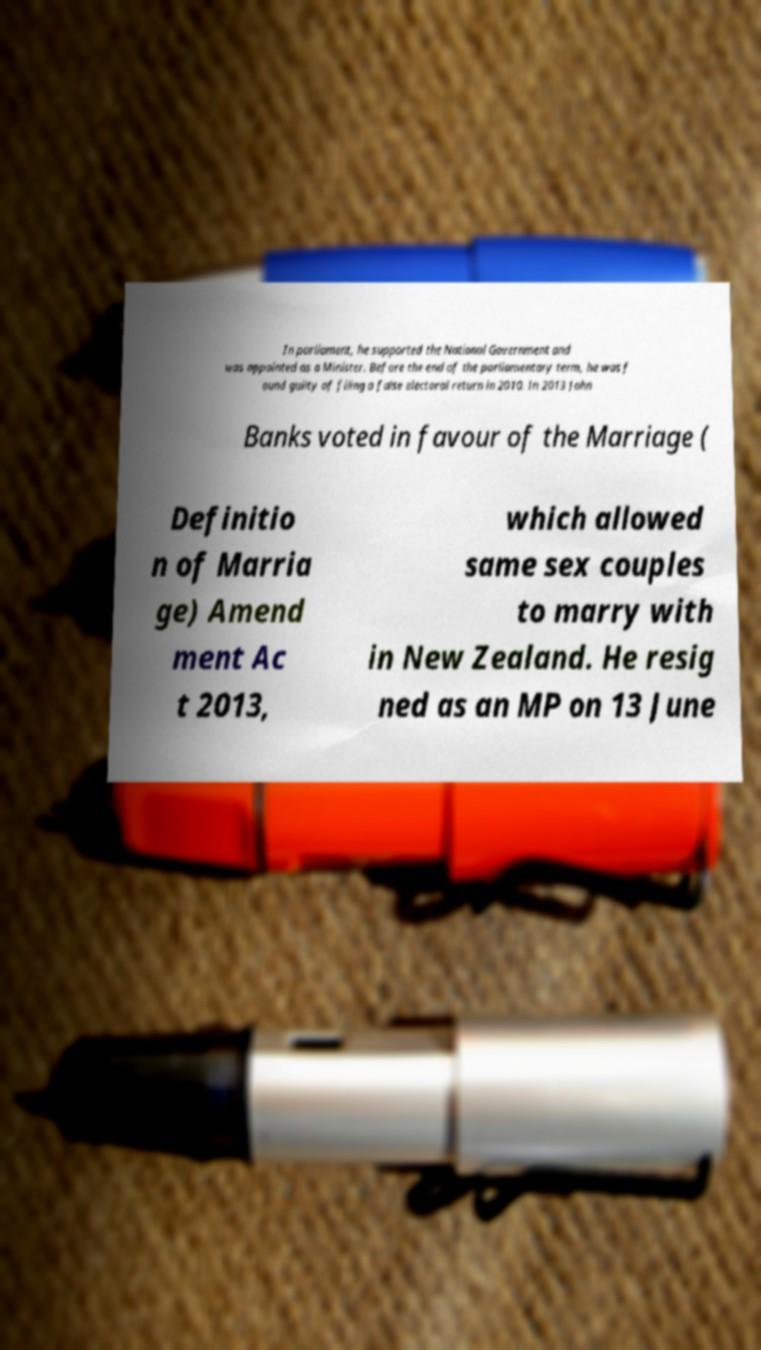Please identify and transcribe the text found in this image. In parliament, he supported the National Government and was appointed as a Minister. Before the end of the parliamentary term, he was f ound guilty of filing a false electoral return in 2010. In 2013 John Banks voted in favour of the Marriage ( Definitio n of Marria ge) Amend ment Ac t 2013, which allowed same sex couples to marry with in New Zealand. He resig ned as an MP on 13 June 